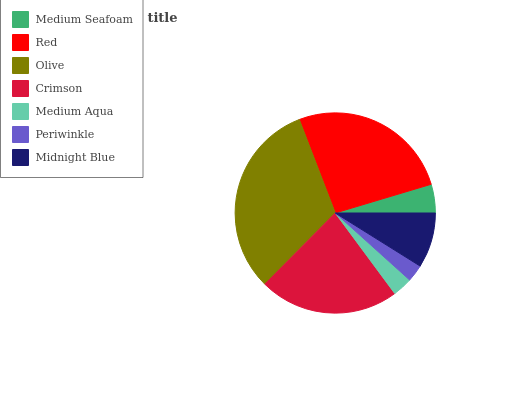Is Periwinkle the minimum?
Answer yes or no. Yes. Is Olive the maximum?
Answer yes or no. Yes. Is Red the minimum?
Answer yes or no. No. Is Red the maximum?
Answer yes or no. No. Is Red greater than Medium Seafoam?
Answer yes or no. Yes. Is Medium Seafoam less than Red?
Answer yes or no. Yes. Is Medium Seafoam greater than Red?
Answer yes or no. No. Is Red less than Medium Seafoam?
Answer yes or no. No. Is Midnight Blue the high median?
Answer yes or no. Yes. Is Midnight Blue the low median?
Answer yes or no. Yes. Is Medium Seafoam the high median?
Answer yes or no. No. Is Medium Seafoam the low median?
Answer yes or no. No. 